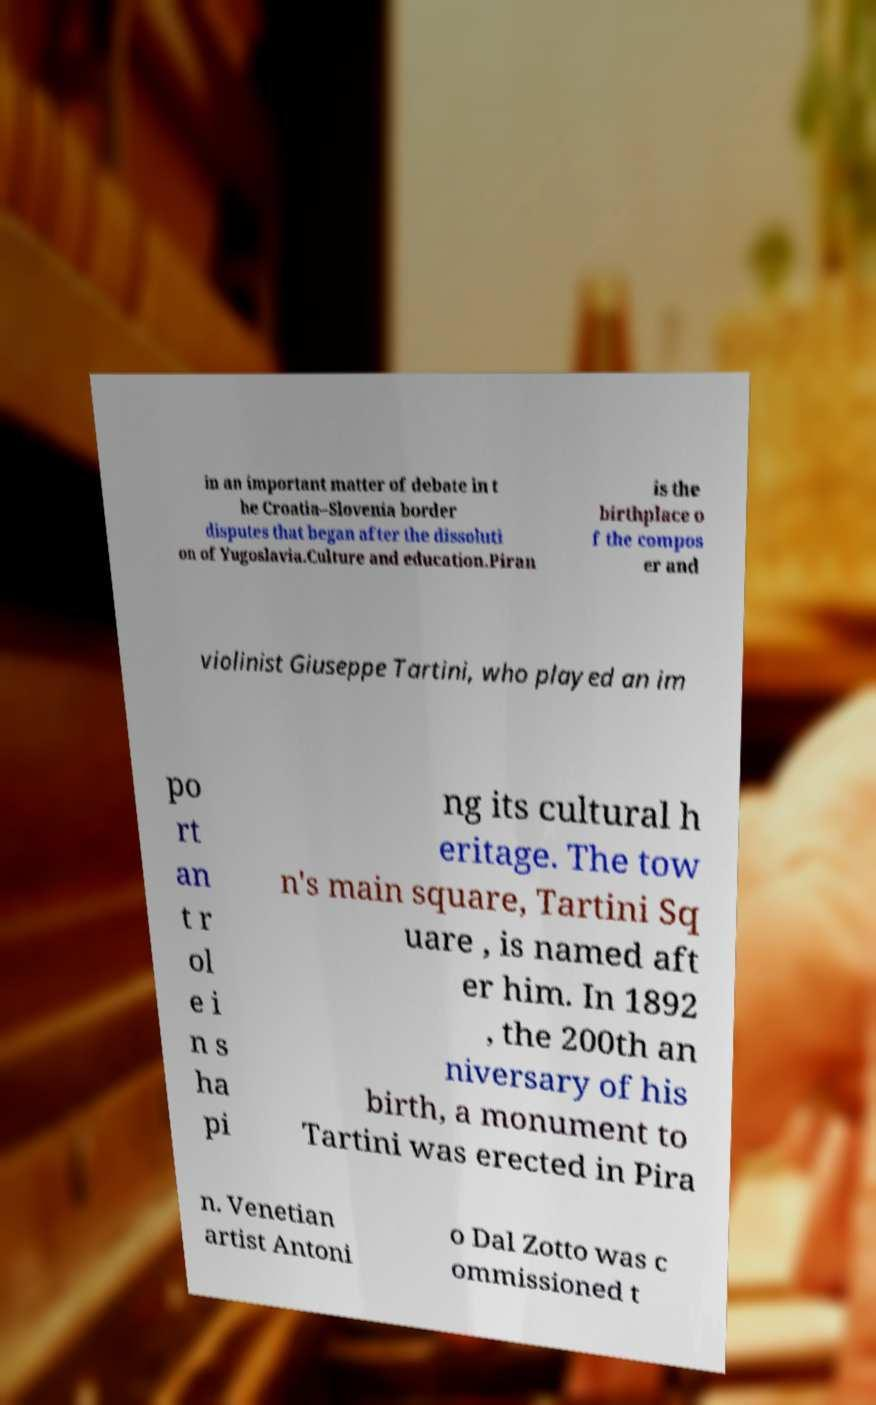Can you accurately transcribe the text from the provided image for me? in an important matter of debate in t he Croatia–Slovenia border disputes that began after the dissoluti on of Yugoslavia.Culture and education.Piran is the birthplace o f the compos er and violinist Giuseppe Tartini, who played an im po rt an t r ol e i n s ha pi ng its cultural h eritage. The tow n's main square, Tartini Sq uare , is named aft er him. In 1892 , the 200th an niversary of his birth, a monument to Tartini was erected in Pira n. Venetian artist Antoni o Dal Zotto was c ommissioned t 